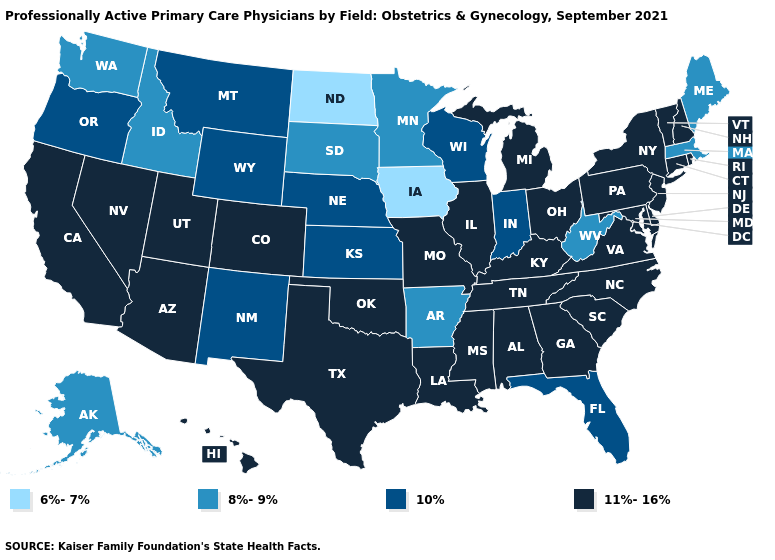Which states have the highest value in the USA?
Keep it brief. Alabama, Arizona, California, Colorado, Connecticut, Delaware, Georgia, Hawaii, Illinois, Kentucky, Louisiana, Maryland, Michigan, Mississippi, Missouri, Nevada, New Hampshire, New Jersey, New York, North Carolina, Ohio, Oklahoma, Pennsylvania, Rhode Island, South Carolina, Tennessee, Texas, Utah, Vermont, Virginia. Does North Dakota have the lowest value in the USA?
Write a very short answer. Yes. Among the states that border Vermont , which have the highest value?
Short answer required. New Hampshire, New York. Name the states that have a value in the range 10%?
Short answer required. Florida, Indiana, Kansas, Montana, Nebraska, New Mexico, Oregon, Wisconsin, Wyoming. What is the value of South Dakota?
Write a very short answer. 8%-9%. Name the states that have a value in the range 6%-7%?
Short answer required. Iowa, North Dakota. Which states have the lowest value in the Northeast?
Concise answer only. Maine, Massachusetts. What is the value of South Carolina?
Concise answer only. 11%-16%. Among the states that border Alabama , which have the lowest value?
Give a very brief answer. Florida. What is the value of Washington?
Answer briefly. 8%-9%. What is the value of Kentucky?
Give a very brief answer. 11%-16%. What is the highest value in the USA?
Short answer required. 11%-16%. Does South Carolina have the same value as Michigan?
Give a very brief answer. Yes. What is the lowest value in states that border Alabama?
Be succinct. 10%. 